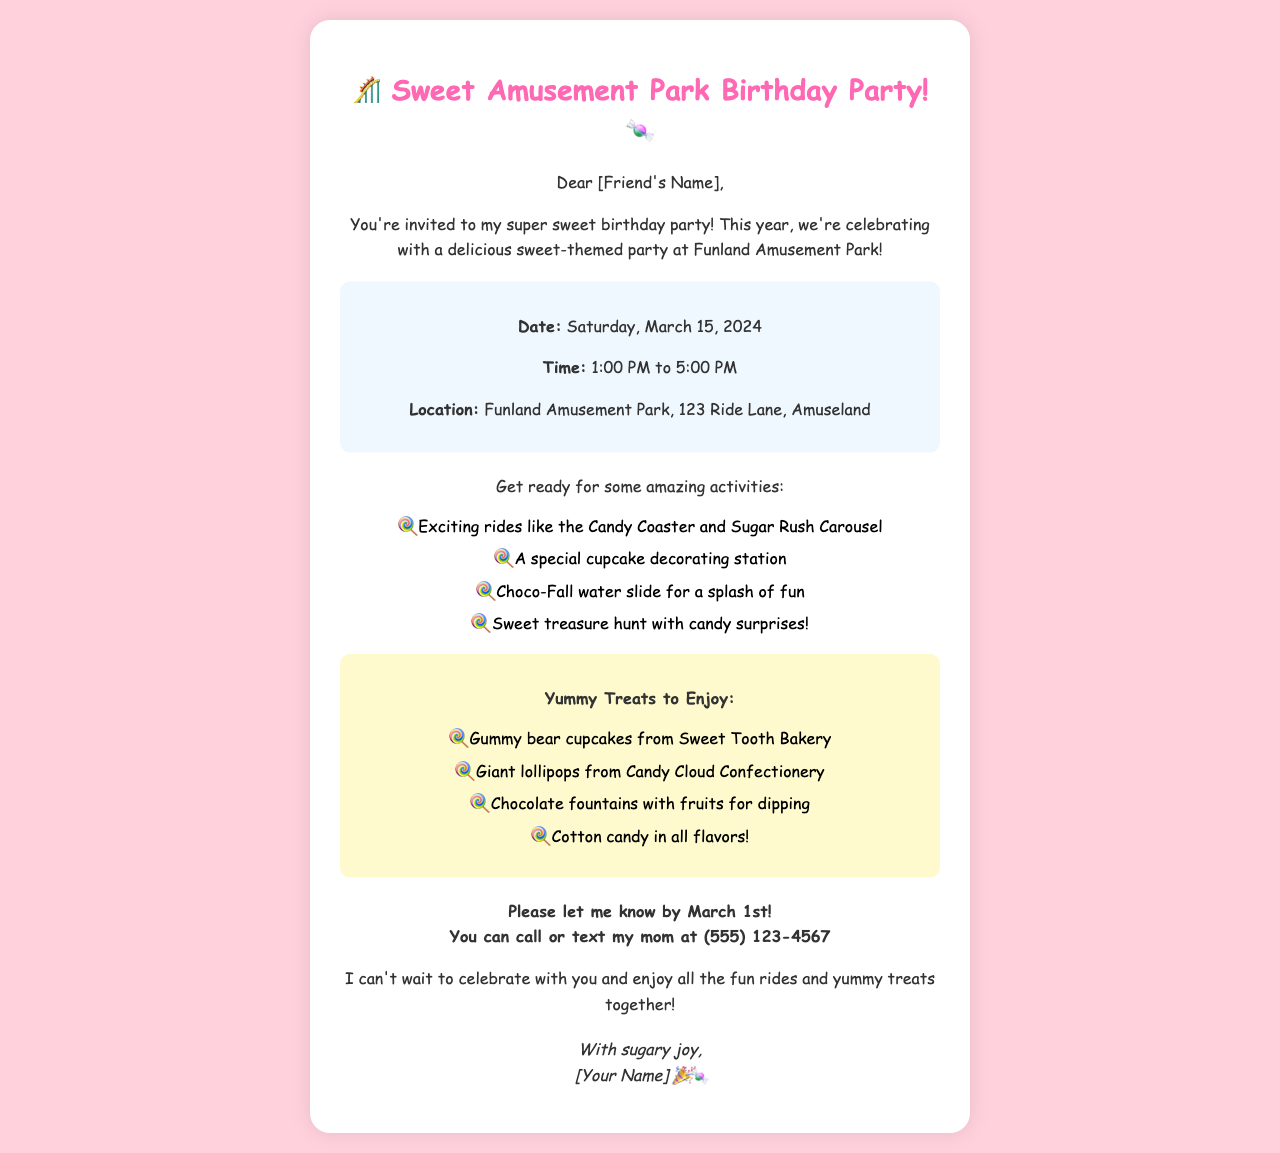What is the date of the party? The date of the party is mentioned in the document as Saturday, March 15, 2024.
Answer: Saturday, March 15, 2024 What is the location of the party? The location of the party is specified as Funland Amusement Park, 123 Ride Lane, Amuseland.
Answer: Funland Amusement Park, 123 Ride Lane, Amuseland What time does the party start? The party starts at 1:00 PM, as stated in the invitation details.
Answer: 1:00 PM What is one of the activities planned? The invitation lists several activities, including a special cupcake decorating station.
Answer: A special cupcake decorating station How should guests RSVP? Guests are requested to RSVP by calling or texting the host's mom at a specified number.
Answer: Call or text my mom at (555) 123-4567 What is one delicious treat mentioned? One of the yummy treats is gummy bear cupcakes from Sweet Tooth Bakery.
Answer: Gummy bear cupcakes from Sweet Tooth Bakery What is the name of the amusement park? The name of the amusement park is Funland, as mentioned in the invitation.
Answer: Funland What is the final signature in the letter? The signature at the end of the letter is “[Your Name]” along with a joyful emoji.
Answer: [Your Name] 🎉🍬 